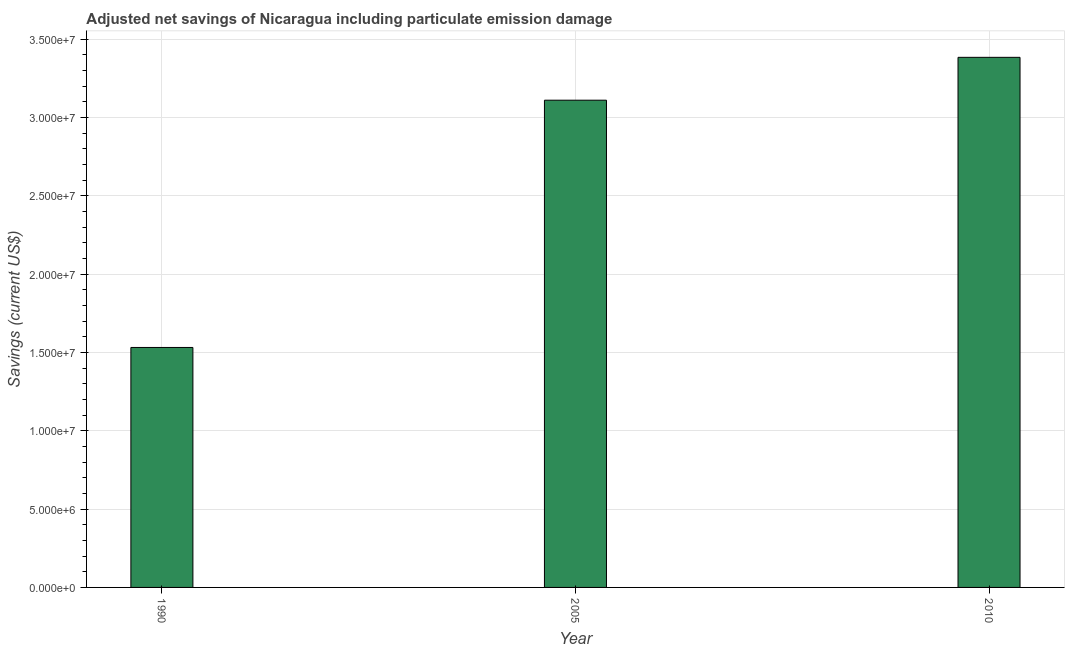What is the title of the graph?
Give a very brief answer. Adjusted net savings of Nicaragua including particulate emission damage. What is the label or title of the X-axis?
Make the answer very short. Year. What is the label or title of the Y-axis?
Your answer should be very brief. Savings (current US$). What is the adjusted net savings in 2005?
Ensure brevity in your answer.  3.11e+07. Across all years, what is the maximum adjusted net savings?
Your response must be concise. 3.38e+07. Across all years, what is the minimum adjusted net savings?
Provide a short and direct response. 1.53e+07. In which year was the adjusted net savings maximum?
Your answer should be very brief. 2010. What is the sum of the adjusted net savings?
Your answer should be very brief. 8.03e+07. What is the difference between the adjusted net savings in 2005 and 2010?
Offer a terse response. -2.74e+06. What is the average adjusted net savings per year?
Provide a short and direct response. 2.68e+07. What is the median adjusted net savings?
Provide a succinct answer. 3.11e+07. Do a majority of the years between 1990 and 2005 (inclusive) have adjusted net savings greater than 4000000 US$?
Your response must be concise. Yes. What is the ratio of the adjusted net savings in 1990 to that in 2010?
Make the answer very short. 0.45. Is the adjusted net savings in 1990 less than that in 2005?
Your answer should be very brief. Yes. Is the difference between the adjusted net savings in 1990 and 2010 greater than the difference between any two years?
Provide a short and direct response. Yes. What is the difference between the highest and the second highest adjusted net savings?
Provide a short and direct response. 2.74e+06. What is the difference between the highest and the lowest adjusted net savings?
Make the answer very short. 1.85e+07. In how many years, is the adjusted net savings greater than the average adjusted net savings taken over all years?
Make the answer very short. 2. How many bars are there?
Provide a succinct answer. 3. What is the difference between two consecutive major ticks on the Y-axis?
Provide a short and direct response. 5.00e+06. Are the values on the major ticks of Y-axis written in scientific E-notation?
Your answer should be very brief. Yes. What is the Savings (current US$) of 1990?
Provide a succinct answer. 1.53e+07. What is the Savings (current US$) in 2005?
Provide a succinct answer. 3.11e+07. What is the Savings (current US$) of 2010?
Provide a succinct answer. 3.38e+07. What is the difference between the Savings (current US$) in 1990 and 2005?
Ensure brevity in your answer.  -1.58e+07. What is the difference between the Savings (current US$) in 1990 and 2010?
Your answer should be compact. -1.85e+07. What is the difference between the Savings (current US$) in 2005 and 2010?
Your response must be concise. -2.74e+06. What is the ratio of the Savings (current US$) in 1990 to that in 2005?
Provide a succinct answer. 0.49. What is the ratio of the Savings (current US$) in 1990 to that in 2010?
Offer a very short reply. 0.45. What is the ratio of the Savings (current US$) in 2005 to that in 2010?
Keep it short and to the point. 0.92. 